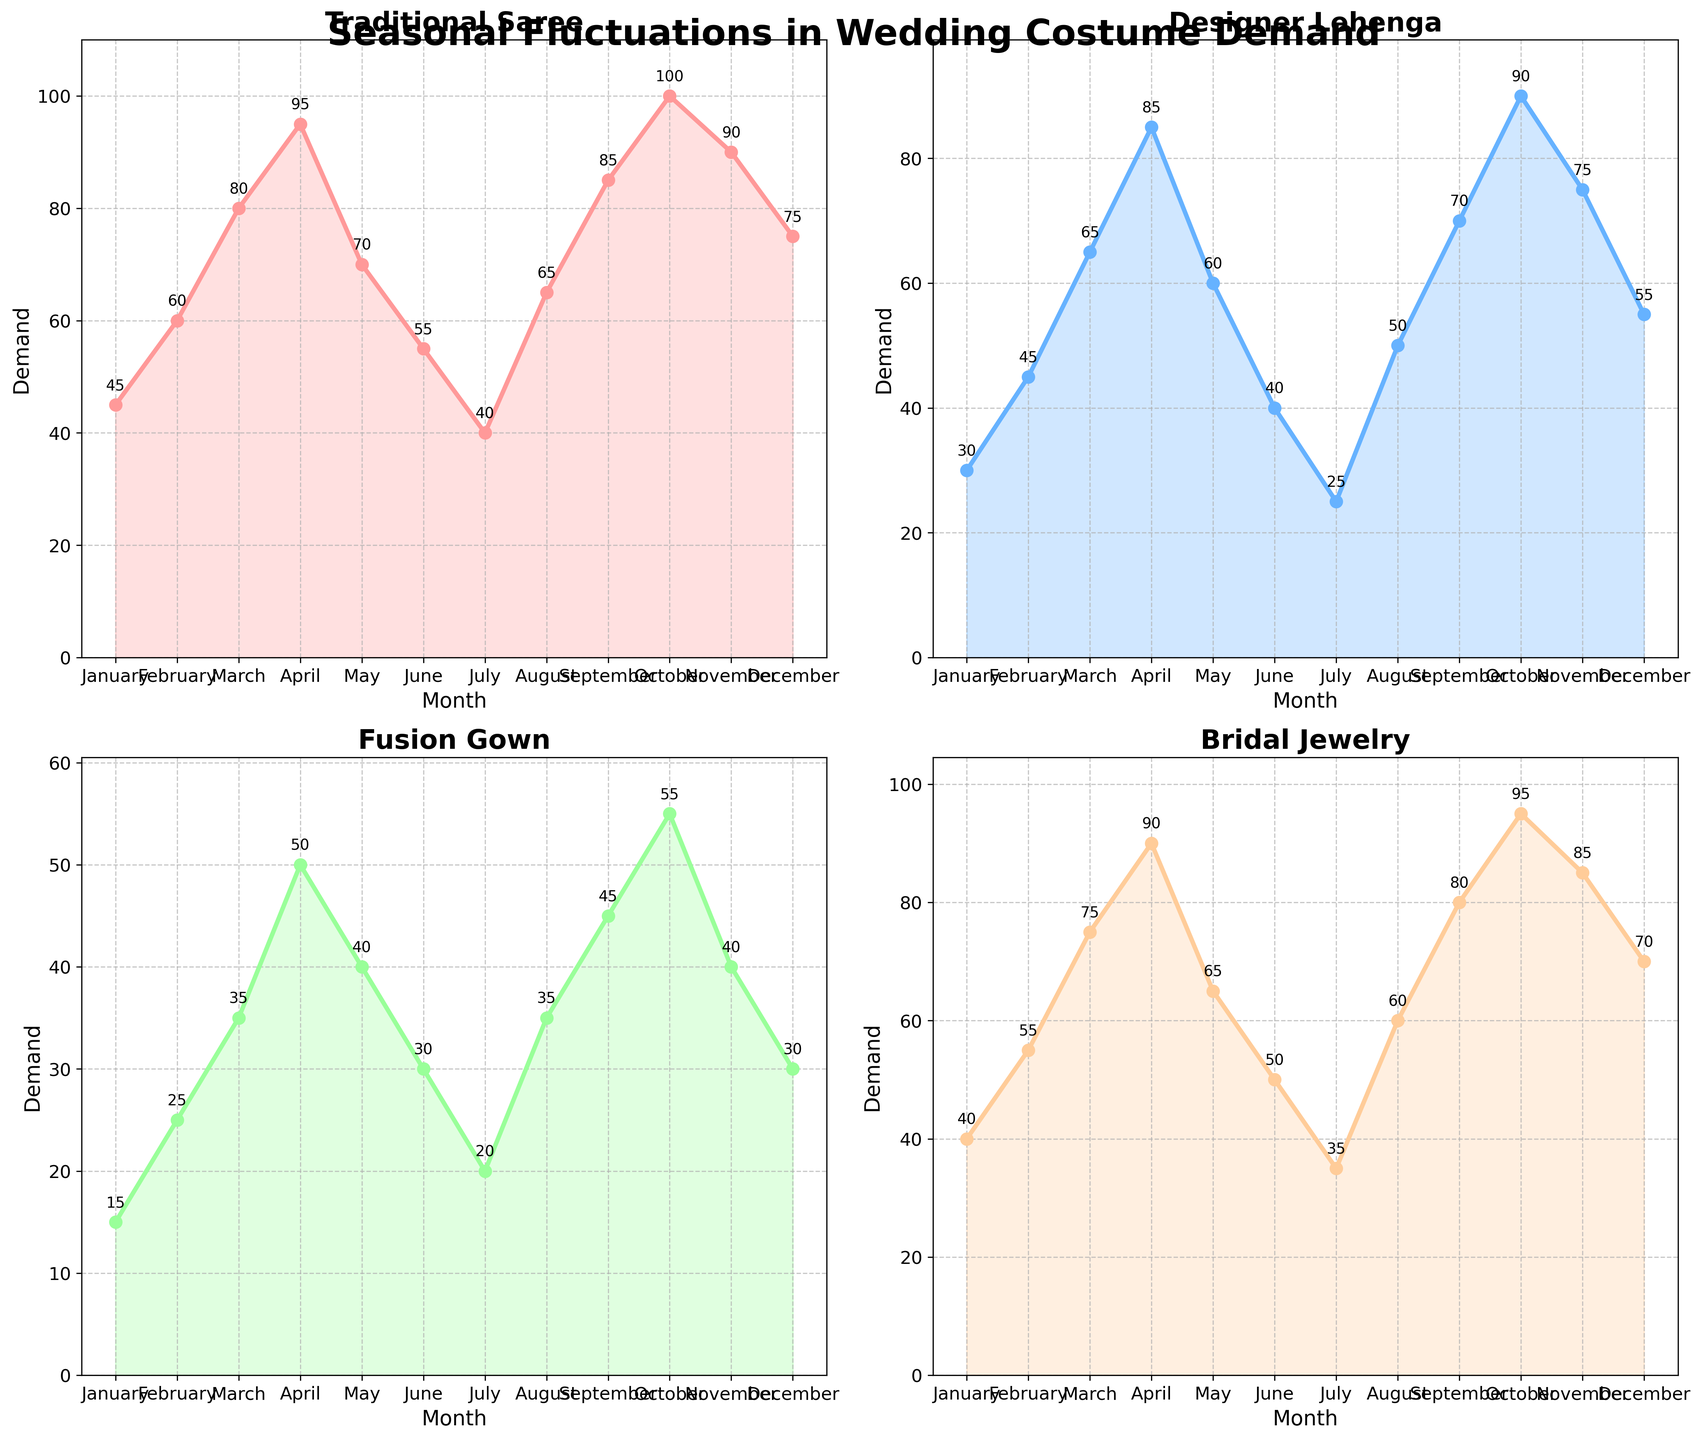Which month has the highest demand for Traditional Sarees? The highest point on the Traditional Saree plot corresponds to October.
Answer: October How does the demand for Designer Lehenga change from January to March? The demand for Designer Lehenga increases gradually from January (30) to February (45) and then to March (65).
Answer: It increases During which month is the demand for Fusion Gowns the lowest? The lowest point on the Fusion Gown plot is in July.
Answer: July Which item has the highest demand in February? In February, the Bridal Jewelry plot reaches 55, which is higher than the demands for Traditional Saree (60), Designer Lehenga (45), and Fusion Gown (25).
Answer: Bridal Jewelry What is the average demand for Bridal Jewelry over the year? The sum of the demands for Bridal Jewelry over each month is 40 + 55 + 75 + 90 + 65 + 50 + 35 + 60 + 80 + 95 + 85 + 70 = 800. There are 12 months, so the average is 800 / 12 ≈ 66.67
Answer: 66.67 Which month shows a peak demand for Designer Lehenga? The peak demand for Designer Lehenga is seen in October.
Answer: October Compare the demand for Traditional Saree and Fusion Gown in June. Which one is higher and by how much? In June, the demand for Traditional Saree is 55, while for Fusion Gown it is 30. The difference is 55 - 30 = 25.
Answer: Traditional Saree by 25 What is the trend for the demand for Bridal Jewelry from April to July? From April (90) to May (65) to June (50) to July (35), the demand for Bridal Jewelry shows a decreasing trend.
Answer: Decreasing Calculate the combined demand for all items in November. The combined demand in November is 90 (Traditional Saree) + 75 (Designer Lehenga) + 40 (Fusion Gown) + 85 (Bridal Jewelry) = 290.
Answer: 290 Which item shows the most fluctuation in demand throughout the year? By observing the plots, the Traditional Saree demand shows the widest range from 40 to 100, indicating the most fluctuation.
Answer: Traditional Saree 